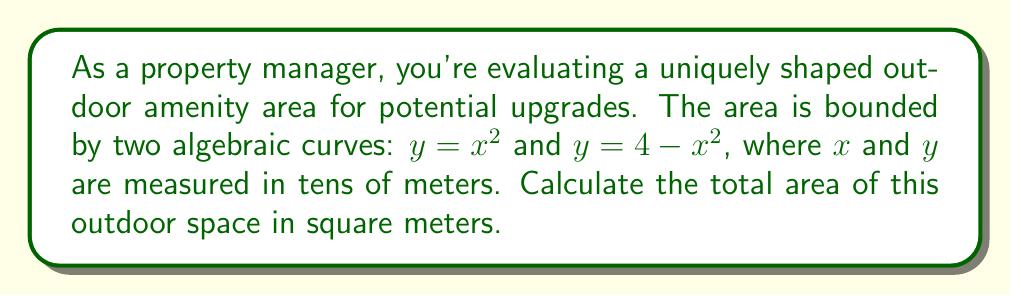Can you answer this question? Let's approach this step-by-step:

1) The area we're looking for is bounded by two curves: $y = x^2$ and $y = 4 - x^2$

2) To find the points of intersection, we set the equations equal to each other:
   $x^2 = 4 - x^2$
   $2x^2 = 4$
   $x^2 = 2$
   $x = \pm\sqrt{2}$

3) The area is symmetric about the y-axis, so we can calculate the area of one half and double it.

4) The area can be found by integrating the difference between the two curves from 0 to $\sqrt{2}$:

   Area = $2 \int_0^{\sqrt{2}} [(4 - x^2) - x^2] dx$

5) Simplify the integrand:
   Area = $2 \int_0^{\sqrt{2}} (4 - 2x^2) dx$

6) Integrate:
   Area = $2 [4x - \frac{2x^3}{3}]_0^{\sqrt{2}}$

7) Evaluate the definite integral:
   Area = $2 [(4\sqrt{2} - \frac{2(\sqrt{2})^3}{3}) - (0)]$
        = $2 [4\sqrt{2} - \frac{4\sqrt{2}}{3}]$
        = $2 [\frac{12\sqrt{2}}{3} - \frac{4\sqrt{2}}{3}]$
        = $2 [\frac{8\sqrt{2}}{3}]$
        = $\frac{16\sqrt{2}}{3}$

8) Remember, x and y were measured in tens of meters, so we need to multiply our result by 100 to get square meters:

   Final Area = $\frac{1600\sqrt{2}}{3}$ square meters
Answer: $\frac{1600\sqrt{2}}{3}$ m² 